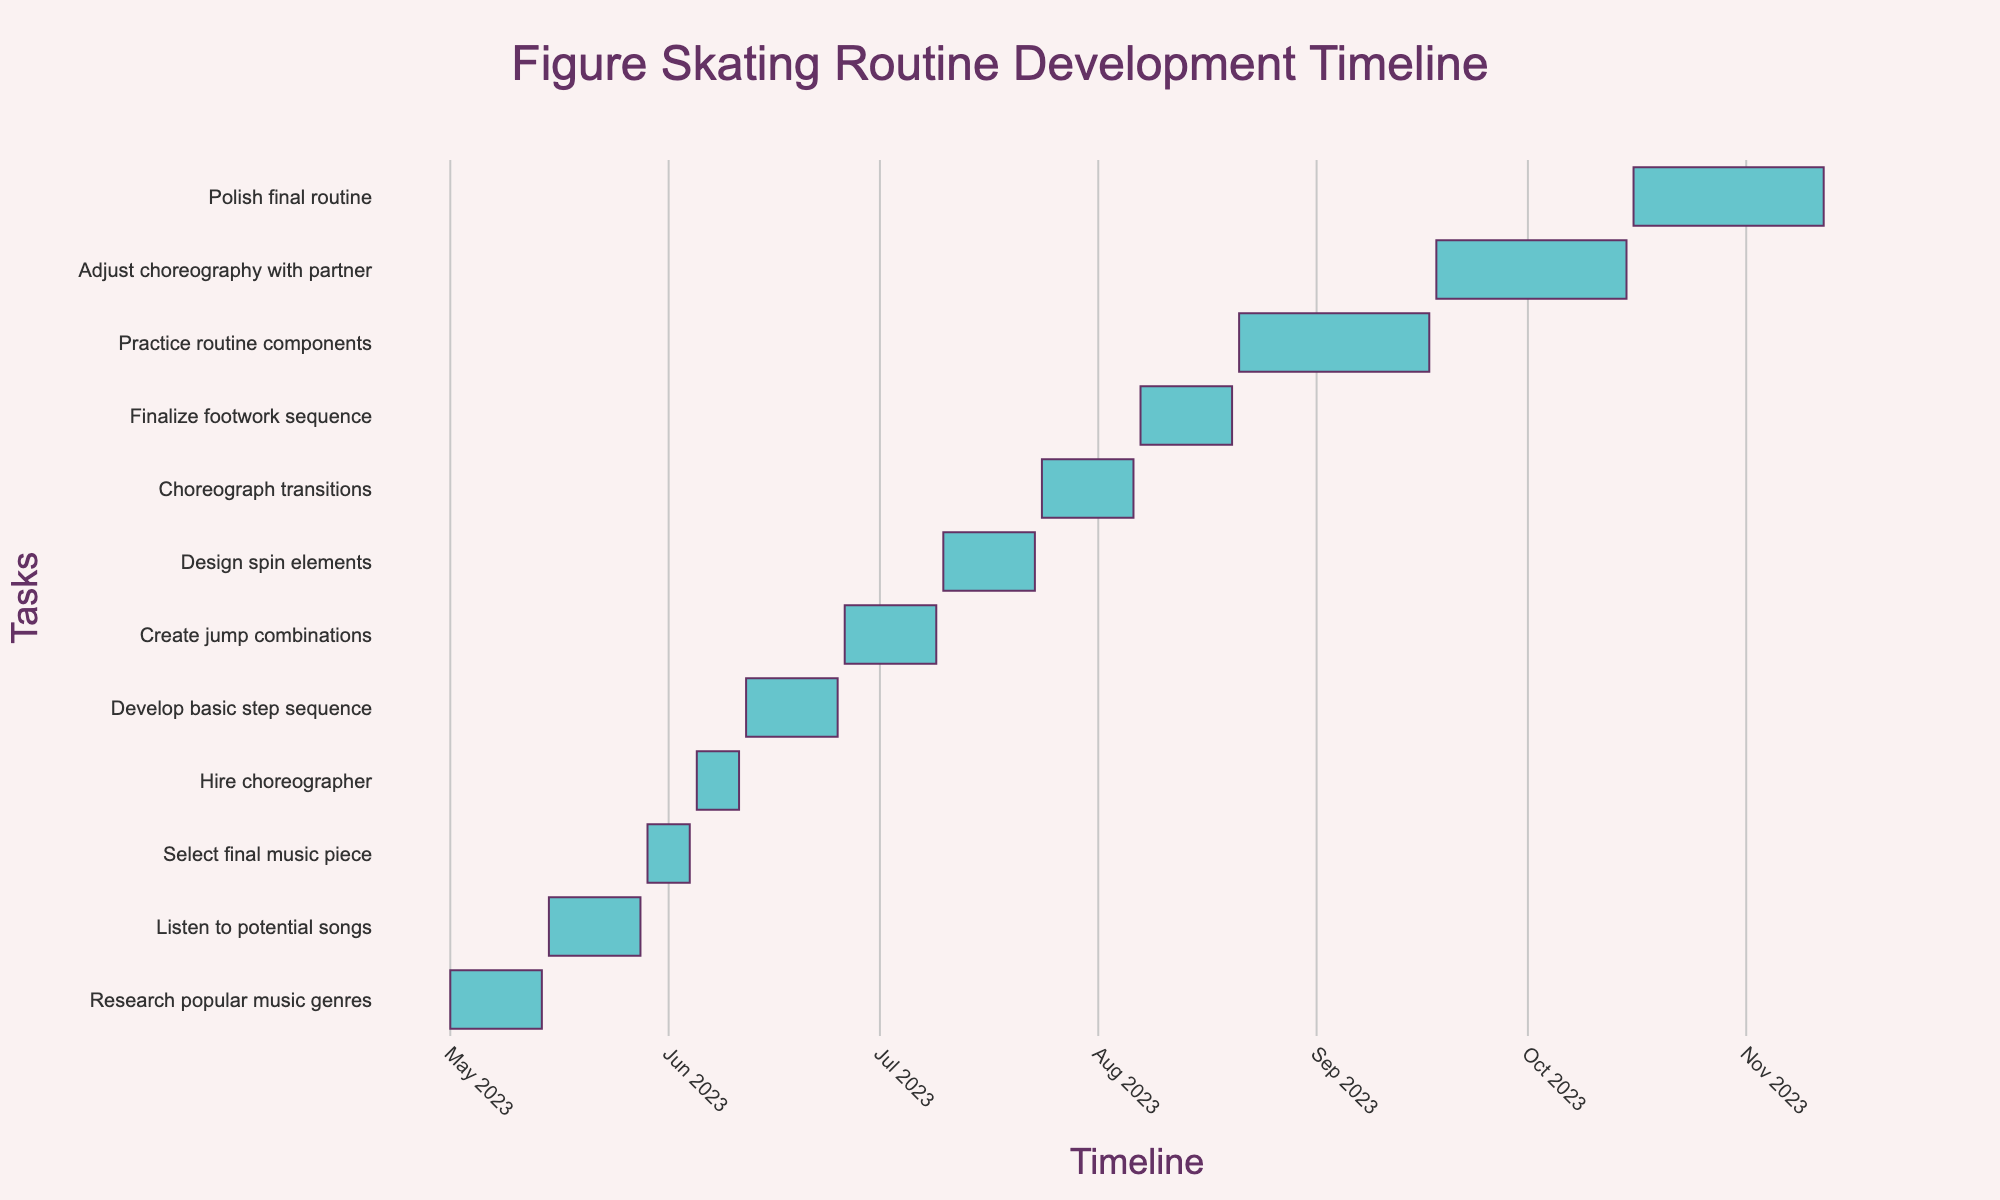What is the title of the Gantt chart? The title of the Gantt chart is typically displayed at the top, centered in this case. It can be read directly from the figure.
Answer: Figure Skating Routine Development Timeline Between which dates is the task "Hire choreographer" scheduled? The task "Hire choreographer" can be located in the list of tasks on the y-axis, and the corresponding bar on the timeline shows the start and end dates.
Answer: June 5, 2023 - June 11, 2023 How long is the "Select final music piece" task? This requires calculating the difference between the start and end dates for the task. The task "Select final music piece" is scheduled from May 29, 2023, to June 4, 2023, so calculate the number of days between these dates.
Answer: 7 days Which task is scheduled immediately after "Develop basic step sequence"? To find this, look at the order of the tasks. "Develop basic step sequence" ends on June 25, 2023, and the task that starts right after it should be identified.
Answer: Create jump combinations How many tasks are there in total? Count the total number of tasks listed on the y-axis. Each task corresponds to a bar in the timeline.
Answer: 12 Which task has the longest duration? Check the start and end dates for each task and determine which task spans the most days. The task starting from August 21, 2023, and ending on September 17, 2023, appears longer.
Answer: Practice routine components How many tasks are scheduled in the month of July? Identify tasks that either start or end, or span across the month of July. Count these tasks.
Answer: 3 What is the overlapping period between the tasks "Practice routine components" and "Adjust choreography with partner"? Determine the timeline of both tasks and calculate the common dates. "Practice routine components" ends on September 17, 2023, and "Adjust choreography with partner" starts on September 18, 2023.
Answer: No overlap Which tasks are scheduled in August? Identify tasks that have any dates in August. List these tasks looking at the relevant dates on the chart.
Answer: Finalize footwork sequence, Practice routine components In what month does the "Polish final routine" task conclude? Look at the end date for "Polish final routine" and determine the corresponding month.
Answer: November 